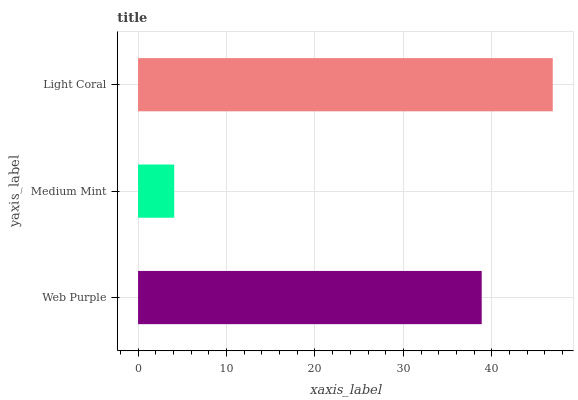Is Medium Mint the minimum?
Answer yes or no. Yes. Is Light Coral the maximum?
Answer yes or no. Yes. Is Light Coral the minimum?
Answer yes or no. No. Is Medium Mint the maximum?
Answer yes or no. No. Is Light Coral greater than Medium Mint?
Answer yes or no. Yes. Is Medium Mint less than Light Coral?
Answer yes or no. Yes. Is Medium Mint greater than Light Coral?
Answer yes or no. No. Is Light Coral less than Medium Mint?
Answer yes or no. No. Is Web Purple the high median?
Answer yes or no. Yes. Is Web Purple the low median?
Answer yes or no. Yes. Is Medium Mint the high median?
Answer yes or no. No. Is Light Coral the low median?
Answer yes or no. No. 